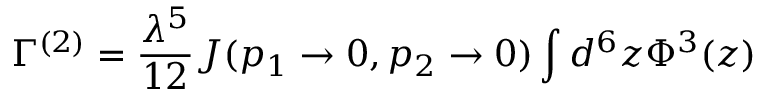<formula> <loc_0><loc_0><loc_500><loc_500>\Gamma ^ { ( 2 ) } = \frac { \lambda ^ { 5 } } { 1 2 } J ( p _ { 1 } \rightarrow 0 , p _ { 2 } \rightarrow 0 ) \int d ^ { 6 } z \Phi ^ { 3 } ( z )</formula> 